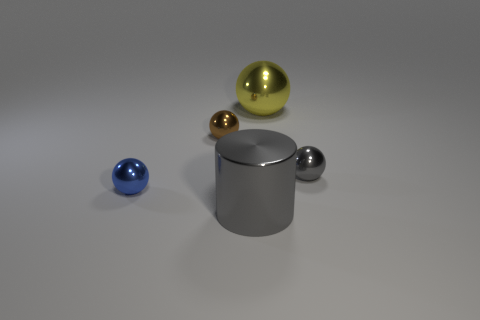What can you infer about the lighting and texture of the objects? The lighting in the image appears to be coming from above, casting subtle shadows beneath the objects. The objects themselves have different textures, with the spheres looking glossy and reflective, while the cylinder has a more matte finish. 